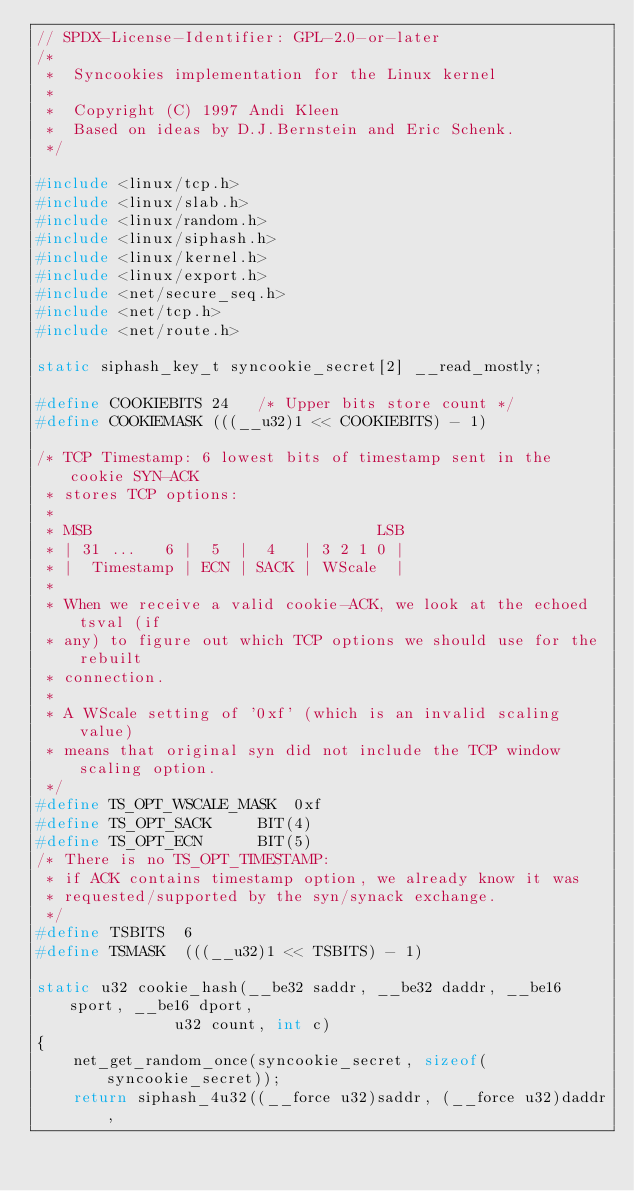Convert code to text. <code><loc_0><loc_0><loc_500><loc_500><_C_>// SPDX-License-Identifier: GPL-2.0-or-later
/*
 *  Syncookies implementation for the Linux kernel
 *
 *  Copyright (C) 1997 Andi Kleen
 *  Based on ideas by D.J.Bernstein and Eric Schenk.
 */

#include <linux/tcp.h>
#include <linux/slab.h>
#include <linux/random.h>
#include <linux/siphash.h>
#include <linux/kernel.h>
#include <linux/export.h>
#include <net/secure_seq.h>
#include <net/tcp.h>
#include <net/route.h>

static siphash_key_t syncookie_secret[2] __read_mostly;

#define COOKIEBITS 24	/* Upper bits store count */
#define COOKIEMASK (((__u32)1 << COOKIEBITS) - 1)

/* TCP Timestamp: 6 lowest bits of timestamp sent in the cookie SYN-ACK
 * stores TCP options:
 *
 * MSB                               LSB
 * | 31 ...   6 |  5  |  4   | 3 2 1 0 |
 * |  Timestamp | ECN | SACK | WScale  |
 *
 * When we receive a valid cookie-ACK, we look at the echoed tsval (if
 * any) to figure out which TCP options we should use for the rebuilt
 * connection.
 *
 * A WScale setting of '0xf' (which is an invalid scaling value)
 * means that original syn did not include the TCP window scaling option.
 */
#define TS_OPT_WSCALE_MASK	0xf
#define TS_OPT_SACK		BIT(4)
#define TS_OPT_ECN		BIT(5)
/* There is no TS_OPT_TIMESTAMP:
 * if ACK contains timestamp option, we already know it was
 * requested/supported by the syn/synack exchange.
 */
#define TSBITS	6
#define TSMASK	(((__u32)1 << TSBITS) - 1)

static u32 cookie_hash(__be32 saddr, __be32 daddr, __be16 sport, __be16 dport,
		       u32 count, int c)
{
	net_get_random_once(syncookie_secret, sizeof(syncookie_secret));
	return siphash_4u32((__force u32)saddr, (__force u32)daddr,</code> 